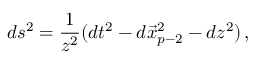<formula> <loc_0><loc_0><loc_500><loc_500>d s ^ { 2 } = \frac { 1 } { z ^ { 2 } } ( d t ^ { 2 } - d \vec { x } _ { p - 2 } ^ { 2 } - d z ^ { 2 } ) \, ,</formula> 